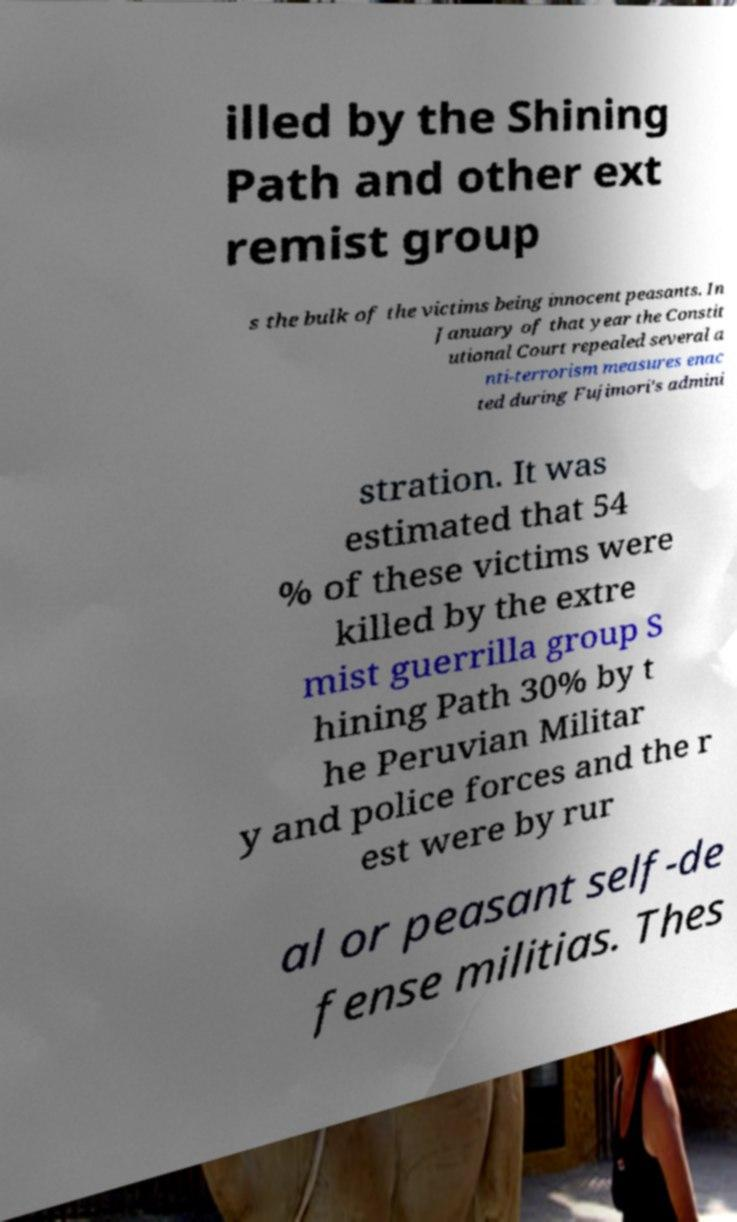Please identify and transcribe the text found in this image. illed by the Shining Path and other ext remist group s the bulk of the victims being innocent peasants. In January of that year the Constit utional Court repealed several a nti-terrorism measures enac ted during Fujimori's admini stration. It was estimated that 54 % of these victims were killed by the extre mist guerrilla group S hining Path 30% by t he Peruvian Militar y and police forces and the r est were by rur al or peasant self-de fense militias. Thes 